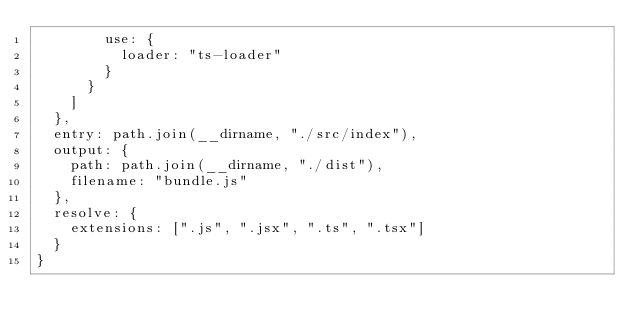Convert code to text. <code><loc_0><loc_0><loc_500><loc_500><_JavaScript_>        use: {
          loader: "ts-loader"
        }
      }
    ]
  },
  entry: path.join(__dirname, "./src/index"),
  output: {
    path: path.join(__dirname, "./dist"),
    filename: "bundle.js"
  },
  resolve: {
    extensions: [".js", ".jsx", ".ts", ".tsx"]
  }
}</code> 